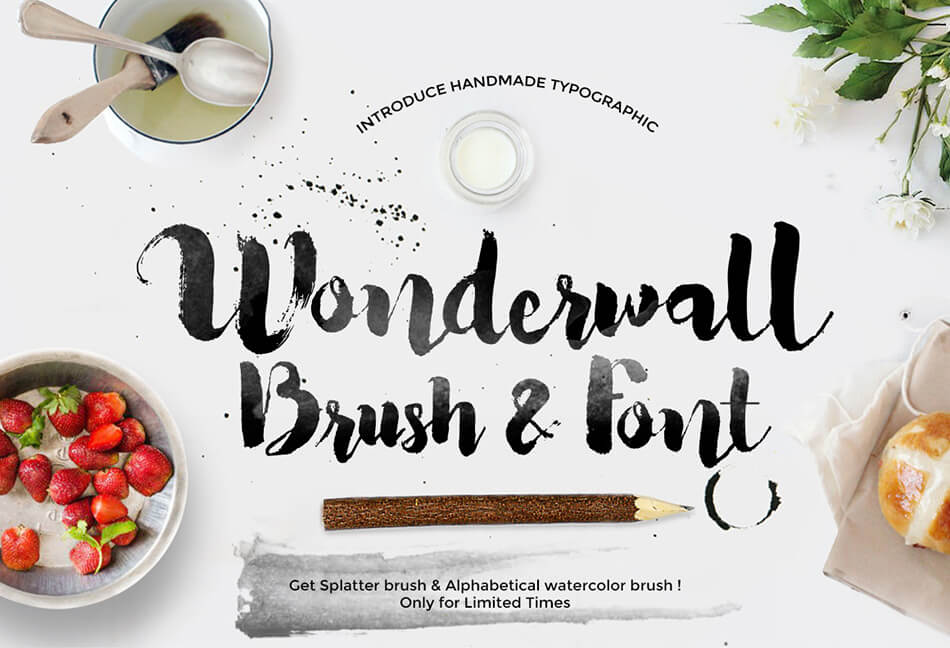How does the overall layout of the elements in the advertisement contribute to the perception of the 'Wonderwall' font and brush's artistic quality? The layout of the advertisement elegantly displays the 'Wonderwall' font and brush by employing a spacious, aesthetically pleasing arrangement that mimics an artist's workspace. This effect not only highlights the handmade quality of the typography but also allows each element, from the splattered paint to the strategically placed strawberries and bread, to contribute to a narrative of creativity and craftsmanship. The use of white space around the text and elements facilitates focus and emphasizes the font’s artistic flair, inviting viewers to imagine these tools in their own projects. 